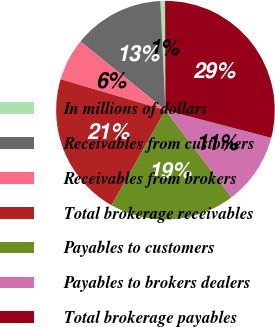Convert chart. <chart><loc_0><loc_0><loc_500><loc_500><pie_chart><fcel>In millions of dollars<fcel>Receivables from customers<fcel>Receivables from brokers<fcel>Total brokerage receivables<fcel>Payables to customers<fcel>Payables to brokers dealers<fcel>Total brokerage payables<nl><fcel>0.69%<fcel>13.44%<fcel>6.25%<fcel>21.37%<fcel>18.53%<fcel>10.6%<fcel>29.13%<nl></chart> 